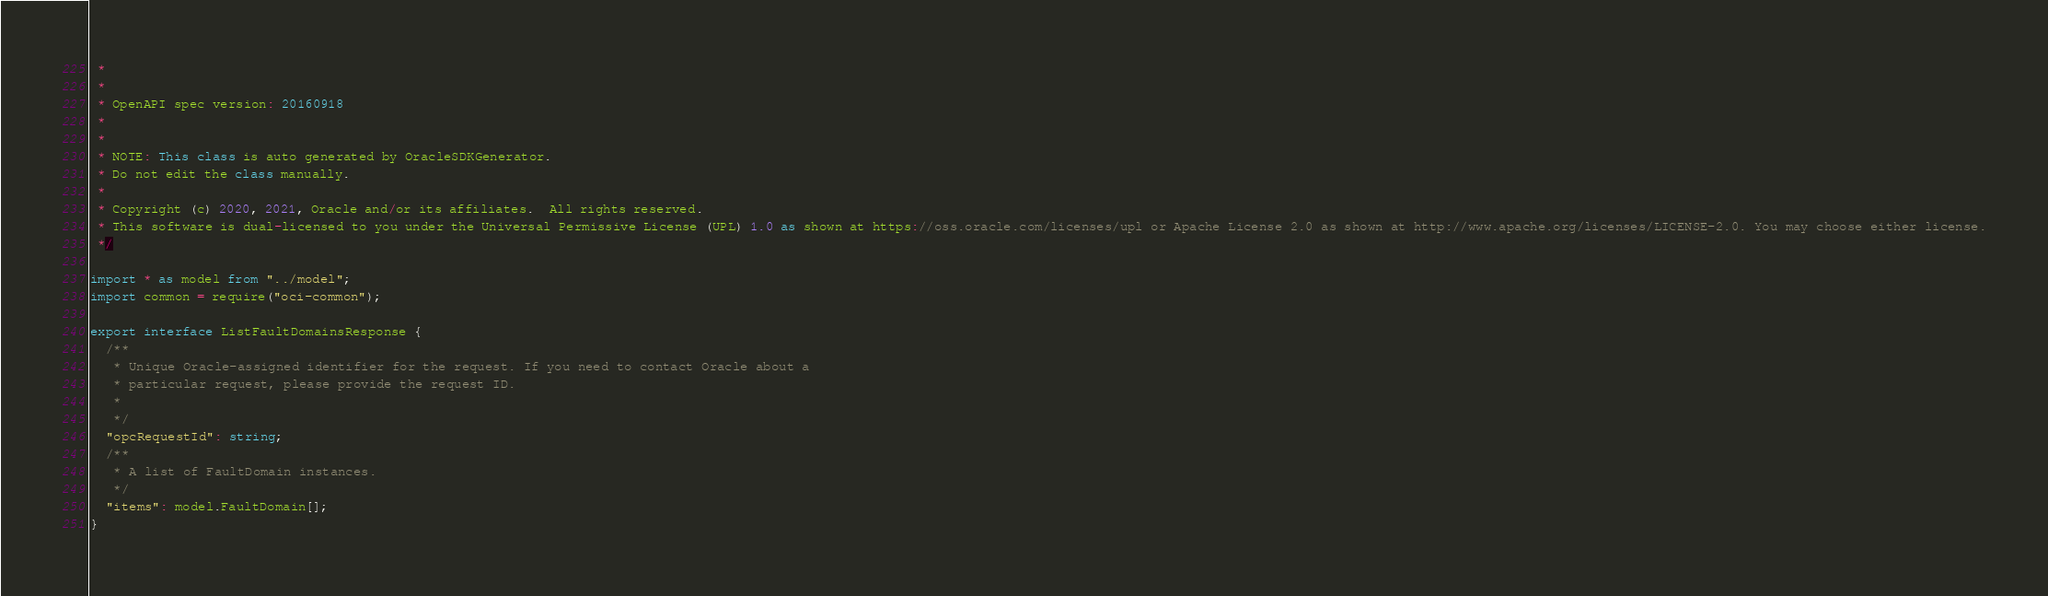<code> <loc_0><loc_0><loc_500><loc_500><_TypeScript_> *
 *
 * OpenAPI spec version: 20160918
 *
 *
 * NOTE: This class is auto generated by OracleSDKGenerator.
 * Do not edit the class manually.
 *
 * Copyright (c) 2020, 2021, Oracle and/or its affiliates.  All rights reserved.
 * This software is dual-licensed to you under the Universal Permissive License (UPL) 1.0 as shown at https://oss.oracle.com/licenses/upl or Apache License 2.0 as shown at http://www.apache.org/licenses/LICENSE-2.0. You may choose either license.
 */

import * as model from "../model";
import common = require("oci-common");

export interface ListFaultDomainsResponse {
  /**
   * Unique Oracle-assigned identifier for the request. If you need to contact Oracle about a
   * particular request, please provide the request ID.
   *
   */
  "opcRequestId": string;
  /**
   * A list of FaultDomain instances.
   */
  "items": model.FaultDomain[];
}
</code> 